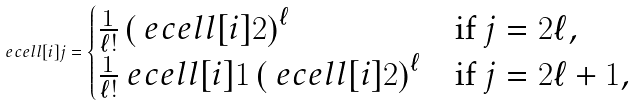<formula> <loc_0><loc_0><loc_500><loc_500>\ e c e l l [ i ] { j } = \begin{cases} \frac { 1 } { \ell ! } \left ( \ e c e l l [ i ] { 2 } \right ) ^ { \ell } & \text {if $j=2\ell$} , \\ \frac { 1 } { \ell ! } \ e c e l l [ i ] { 1 } \left ( \ e c e l l [ i ] { 2 } \right ) ^ { \ell } & \text {if $j=2\ell+1$} , \end{cases}</formula> 